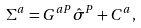<formula> <loc_0><loc_0><loc_500><loc_500>\Sigma ^ { a } = G ^ { a P } \hat { \sigma } ^ { P } + C ^ { a } ,</formula> 